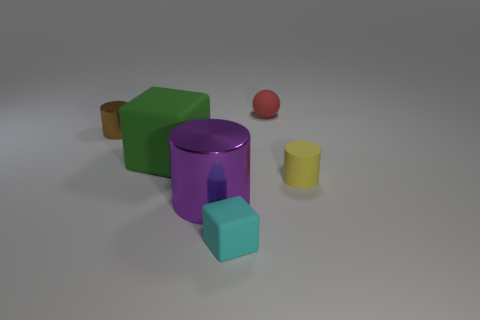Is there any other thing that is the same shape as the small red thing?
Ensure brevity in your answer.  No. What number of brown things are rubber spheres or matte cylinders?
Provide a succinct answer. 0. Is the shape of the small cyan matte object the same as the red object?
Your response must be concise. No. Are there any small objects that are on the left side of the rubber thing on the left side of the cyan thing?
Keep it short and to the point. Yes. Is the number of yellow cylinders that are on the left side of the tiny brown metal thing the same as the number of large green rubber objects?
Your response must be concise. No. How many other objects are there of the same size as the brown shiny cylinder?
Offer a very short reply. 3. Are the small cylinder that is left of the cyan block and the big object that is behind the yellow rubber object made of the same material?
Give a very brief answer. No. There is a shiny cylinder that is right of the block behind the yellow cylinder; what is its size?
Make the answer very short. Large. Are there any metal things that have the same color as the large rubber object?
Provide a succinct answer. No. Do the tiny cylinder that is to the right of the green thing and the small matte object that is left of the tiny ball have the same color?
Your answer should be compact. No. 